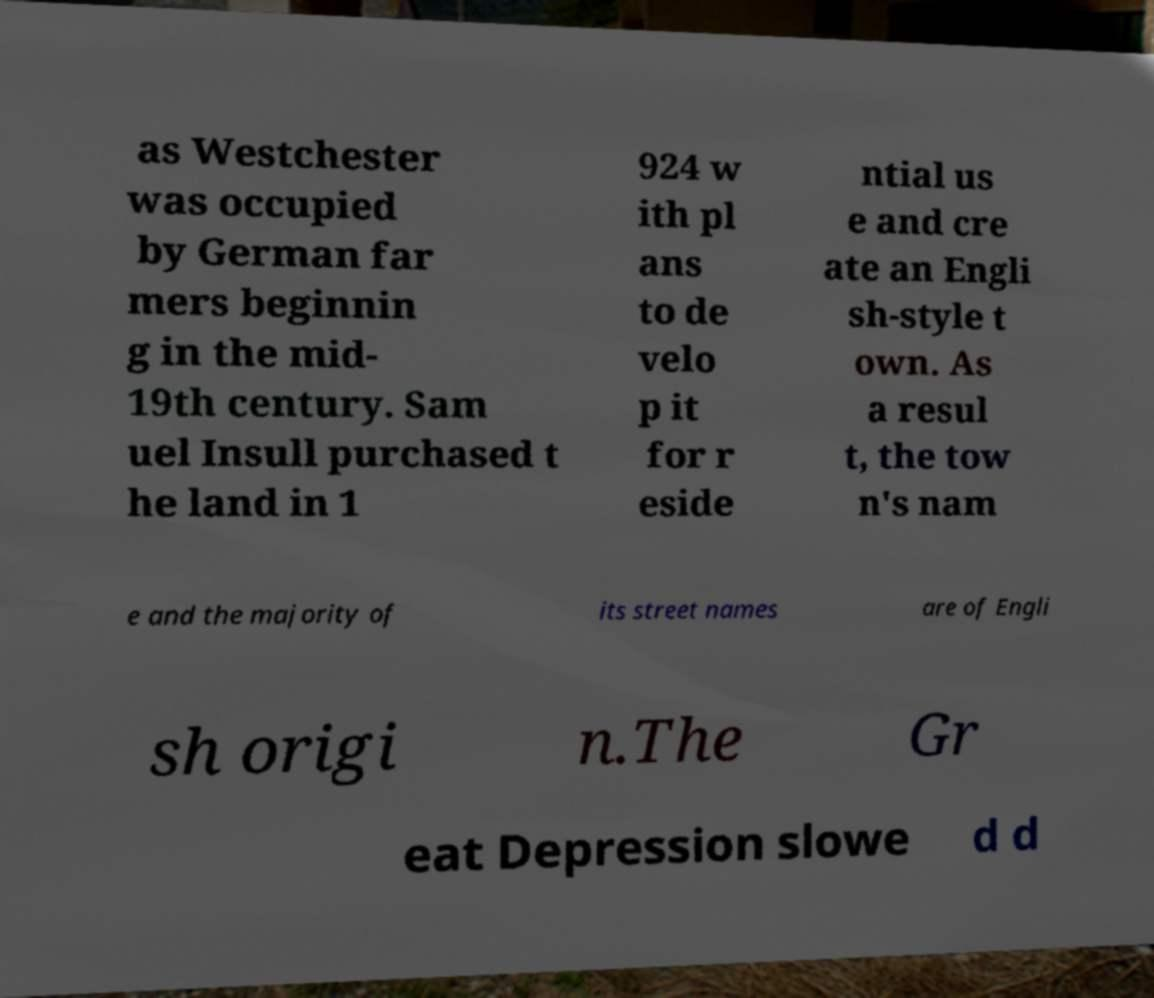Please identify and transcribe the text found in this image. as Westchester was occupied by German far mers beginnin g in the mid- 19th century. Sam uel Insull purchased t he land in 1 924 w ith pl ans to de velo p it for r eside ntial us e and cre ate an Engli sh-style t own. As a resul t, the tow n's nam e and the majority of its street names are of Engli sh origi n.The Gr eat Depression slowe d d 